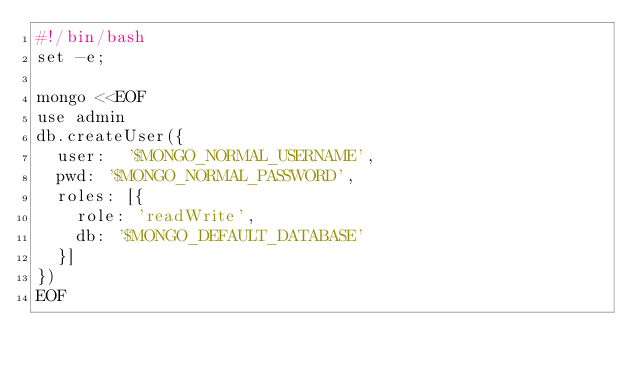<code> <loc_0><loc_0><loc_500><loc_500><_Bash_>#!/bin/bash
set -e;

mongo <<EOF
use admin
db.createUser({
  user:  '$MONGO_NORMAL_USERNAME',
  pwd: '$MONGO_NORMAL_PASSWORD',
  roles: [{
    role: 'readWrite',
    db: '$MONGO_DEFAULT_DATABASE'
  }]
})
EOF</code> 